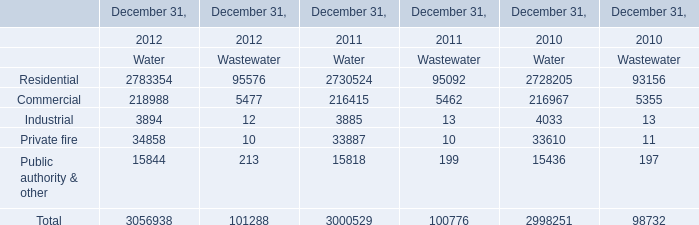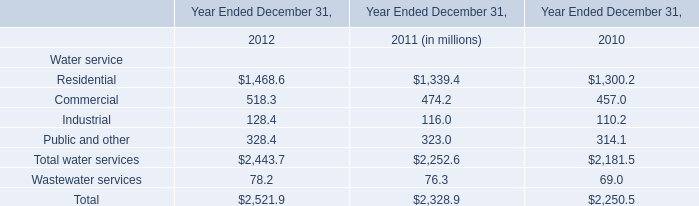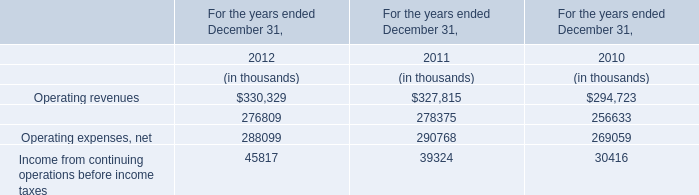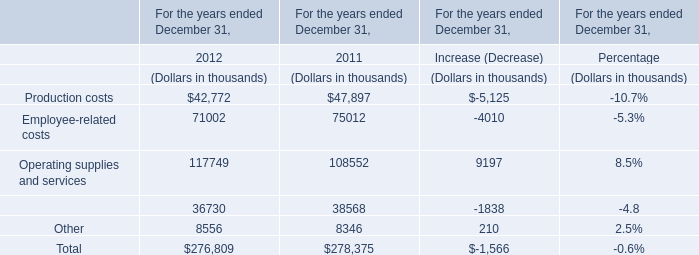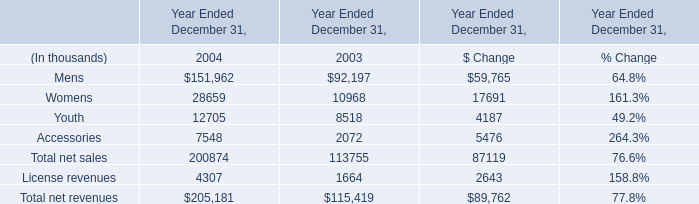What will Operating revenues be like in 2013 if it continues to grow at the same rate as it did in 2012? (in thousand) 
Computations: (330329 * (1 + ((330329 - 327815) / 327815)))
Answer: 332862.27976. 